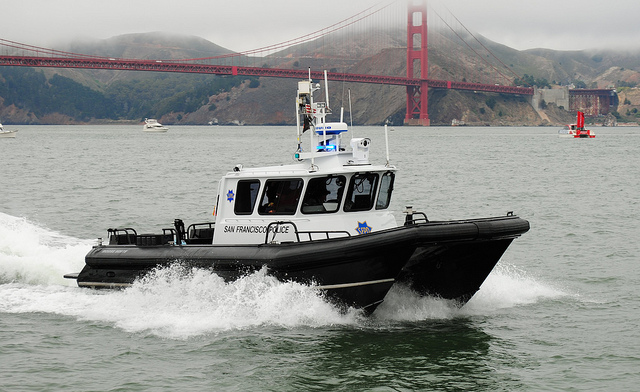Please transcribe the text in this image. SAN FRANCISCO 